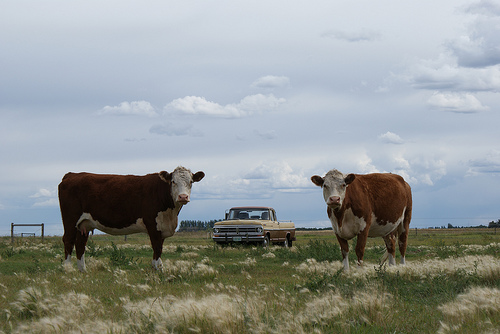<image>
Is the car next to the cow? Yes. The car is positioned adjacent to the cow, located nearby in the same general area. Where is the bull in relation to the field? Is it to the left of the field? No. The bull is not to the left of the field. From this viewpoint, they have a different horizontal relationship. 